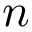Convert formula to latex. <formula><loc_0><loc_0><loc_500><loc_500>n</formula> 